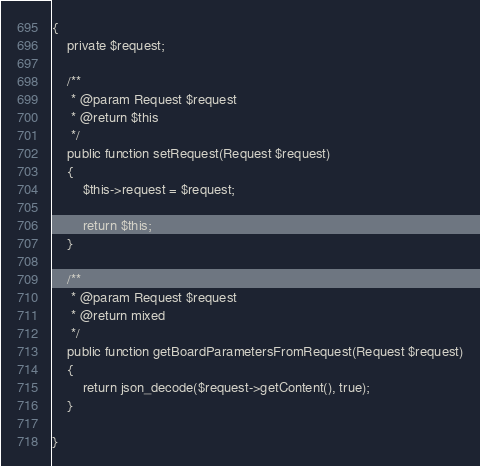Convert code to text. <code><loc_0><loc_0><loc_500><loc_500><_PHP_>{
    private $request;

    /**
     * @param Request $request
     * @return $this
     */
    public function setRequest(Request $request)
    {
        $this->request = $request;

        return $this;
    }

    /**
     * @param Request $request
     * @return mixed
     */
    public function getBoardParametersFromRequest(Request $request)
    {
        return json_decode($request->getContent(), true);
    }

}</code> 